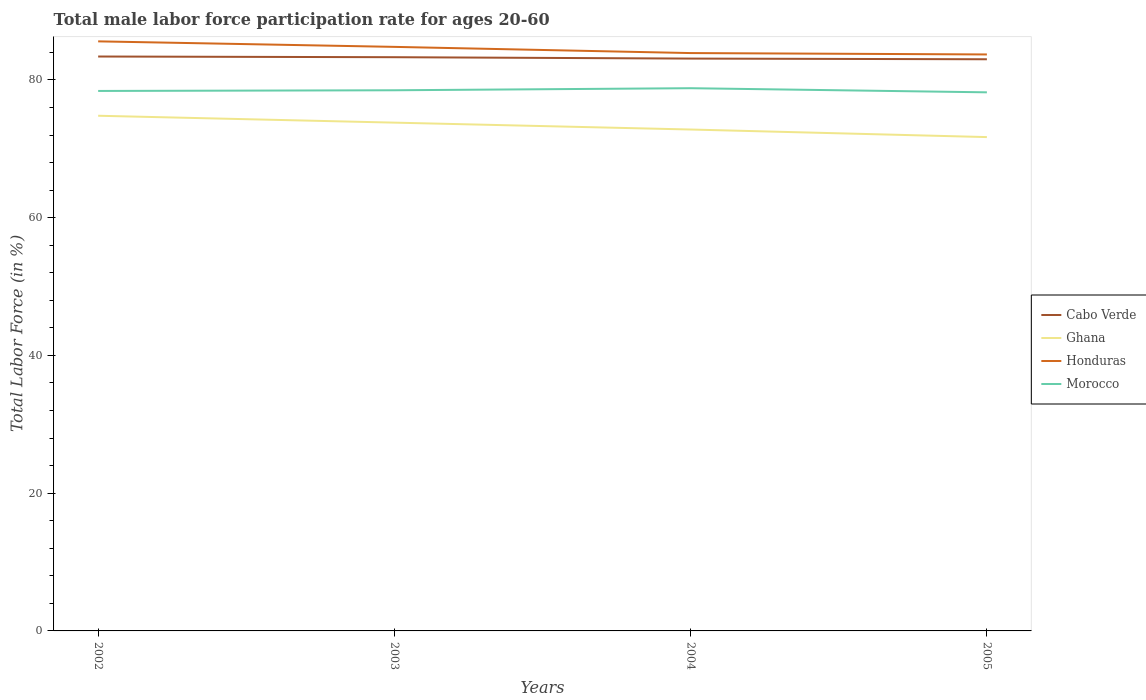How many different coloured lines are there?
Your answer should be compact. 4. Does the line corresponding to Ghana intersect with the line corresponding to Morocco?
Provide a succinct answer. No. Across all years, what is the maximum male labor force participation rate in Honduras?
Give a very brief answer. 83.7. What is the total male labor force participation rate in Honduras in the graph?
Provide a short and direct response. 1.7. What is the difference between the highest and the second highest male labor force participation rate in Honduras?
Make the answer very short. 1.9. How many years are there in the graph?
Offer a terse response. 4. Are the values on the major ticks of Y-axis written in scientific E-notation?
Provide a short and direct response. No. Does the graph contain any zero values?
Provide a short and direct response. No. Where does the legend appear in the graph?
Keep it short and to the point. Center right. How are the legend labels stacked?
Provide a short and direct response. Vertical. What is the title of the graph?
Ensure brevity in your answer.  Total male labor force participation rate for ages 20-60. What is the label or title of the X-axis?
Your response must be concise. Years. What is the Total Labor Force (in %) of Cabo Verde in 2002?
Make the answer very short. 83.4. What is the Total Labor Force (in %) in Ghana in 2002?
Your response must be concise. 74.8. What is the Total Labor Force (in %) in Honduras in 2002?
Your answer should be very brief. 85.6. What is the Total Labor Force (in %) in Morocco in 2002?
Give a very brief answer. 78.4. What is the Total Labor Force (in %) of Cabo Verde in 2003?
Provide a succinct answer. 83.3. What is the Total Labor Force (in %) in Ghana in 2003?
Keep it short and to the point. 73.8. What is the Total Labor Force (in %) in Honduras in 2003?
Keep it short and to the point. 84.8. What is the Total Labor Force (in %) in Morocco in 2003?
Offer a terse response. 78.5. What is the Total Labor Force (in %) of Cabo Verde in 2004?
Give a very brief answer. 83.1. What is the Total Labor Force (in %) in Ghana in 2004?
Your answer should be compact. 72.8. What is the Total Labor Force (in %) of Honduras in 2004?
Make the answer very short. 83.9. What is the Total Labor Force (in %) of Morocco in 2004?
Keep it short and to the point. 78.8. What is the Total Labor Force (in %) of Cabo Verde in 2005?
Make the answer very short. 83. What is the Total Labor Force (in %) in Ghana in 2005?
Make the answer very short. 71.7. What is the Total Labor Force (in %) of Honduras in 2005?
Your answer should be compact. 83.7. What is the Total Labor Force (in %) of Morocco in 2005?
Provide a succinct answer. 78.2. Across all years, what is the maximum Total Labor Force (in %) in Cabo Verde?
Give a very brief answer. 83.4. Across all years, what is the maximum Total Labor Force (in %) of Ghana?
Keep it short and to the point. 74.8. Across all years, what is the maximum Total Labor Force (in %) in Honduras?
Your answer should be compact. 85.6. Across all years, what is the maximum Total Labor Force (in %) in Morocco?
Your answer should be very brief. 78.8. Across all years, what is the minimum Total Labor Force (in %) of Cabo Verde?
Your answer should be compact. 83. Across all years, what is the minimum Total Labor Force (in %) in Ghana?
Make the answer very short. 71.7. Across all years, what is the minimum Total Labor Force (in %) of Honduras?
Keep it short and to the point. 83.7. Across all years, what is the minimum Total Labor Force (in %) in Morocco?
Your answer should be compact. 78.2. What is the total Total Labor Force (in %) of Cabo Verde in the graph?
Offer a terse response. 332.8. What is the total Total Labor Force (in %) of Ghana in the graph?
Your response must be concise. 293.1. What is the total Total Labor Force (in %) of Honduras in the graph?
Offer a terse response. 338. What is the total Total Labor Force (in %) in Morocco in the graph?
Your response must be concise. 313.9. What is the difference between the Total Labor Force (in %) in Honduras in 2002 and that in 2003?
Offer a terse response. 0.8. What is the difference between the Total Labor Force (in %) of Morocco in 2002 and that in 2003?
Provide a short and direct response. -0.1. What is the difference between the Total Labor Force (in %) in Cabo Verde in 2002 and that in 2004?
Give a very brief answer. 0.3. What is the difference between the Total Labor Force (in %) in Ghana in 2002 and that in 2004?
Provide a short and direct response. 2. What is the difference between the Total Labor Force (in %) in Honduras in 2002 and that in 2004?
Your answer should be compact. 1.7. What is the difference between the Total Labor Force (in %) in Morocco in 2002 and that in 2004?
Keep it short and to the point. -0.4. What is the difference between the Total Labor Force (in %) in Honduras in 2002 and that in 2005?
Offer a very short reply. 1.9. What is the difference between the Total Labor Force (in %) of Honduras in 2003 and that in 2004?
Offer a very short reply. 0.9. What is the difference between the Total Labor Force (in %) in Cabo Verde in 2003 and that in 2005?
Make the answer very short. 0.3. What is the difference between the Total Labor Force (in %) in Ghana in 2003 and that in 2005?
Give a very brief answer. 2.1. What is the difference between the Total Labor Force (in %) in Honduras in 2003 and that in 2005?
Your answer should be compact. 1.1. What is the difference between the Total Labor Force (in %) of Cabo Verde in 2004 and that in 2005?
Offer a very short reply. 0.1. What is the difference between the Total Labor Force (in %) of Morocco in 2004 and that in 2005?
Offer a very short reply. 0.6. What is the difference between the Total Labor Force (in %) of Cabo Verde in 2002 and the Total Labor Force (in %) of Honduras in 2003?
Provide a short and direct response. -1.4. What is the difference between the Total Labor Force (in %) of Ghana in 2002 and the Total Labor Force (in %) of Morocco in 2003?
Keep it short and to the point. -3.7. What is the difference between the Total Labor Force (in %) in Cabo Verde in 2002 and the Total Labor Force (in %) in Ghana in 2004?
Your response must be concise. 10.6. What is the difference between the Total Labor Force (in %) in Honduras in 2002 and the Total Labor Force (in %) in Morocco in 2004?
Provide a succinct answer. 6.8. What is the difference between the Total Labor Force (in %) in Cabo Verde in 2002 and the Total Labor Force (in %) in Morocco in 2005?
Offer a terse response. 5.2. What is the difference between the Total Labor Force (in %) in Ghana in 2002 and the Total Labor Force (in %) in Honduras in 2005?
Offer a very short reply. -8.9. What is the difference between the Total Labor Force (in %) in Cabo Verde in 2003 and the Total Labor Force (in %) in Honduras in 2004?
Provide a succinct answer. -0.6. What is the difference between the Total Labor Force (in %) of Honduras in 2003 and the Total Labor Force (in %) of Morocco in 2004?
Offer a terse response. 6. What is the difference between the Total Labor Force (in %) of Cabo Verde in 2003 and the Total Labor Force (in %) of Honduras in 2005?
Give a very brief answer. -0.4. What is the difference between the Total Labor Force (in %) in Cabo Verde in 2003 and the Total Labor Force (in %) in Morocco in 2005?
Your answer should be compact. 5.1. What is the difference between the Total Labor Force (in %) of Ghana in 2003 and the Total Labor Force (in %) of Morocco in 2005?
Make the answer very short. -4.4. What is the difference between the Total Labor Force (in %) of Honduras in 2003 and the Total Labor Force (in %) of Morocco in 2005?
Make the answer very short. 6.6. What is the difference between the Total Labor Force (in %) in Cabo Verde in 2004 and the Total Labor Force (in %) in Morocco in 2005?
Ensure brevity in your answer.  4.9. What is the difference between the Total Labor Force (in %) of Ghana in 2004 and the Total Labor Force (in %) of Honduras in 2005?
Provide a succinct answer. -10.9. What is the difference between the Total Labor Force (in %) in Honduras in 2004 and the Total Labor Force (in %) in Morocco in 2005?
Provide a succinct answer. 5.7. What is the average Total Labor Force (in %) of Cabo Verde per year?
Keep it short and to the point. 83.2. What is the average Total Labor Force (in %) of Ghana per year?
Offer a terse response. 73.28. What is the average Total Labor Force (in %) of Honduras per year?
Your response must be concise. 84.5. What is the average Total Labor Force (in %) in Morocco per year?
Ensure brevity in your answer.  78.47. In the year 2002, what is the difference between the Total Labor Force (in %) of Cabo Verde and Total Labor Force (in %) of Ghana?
Offer a terse response. 8.6. In the year 2002, what is the difference between the Total Labor Force (in %) in Cabo Verde and Total Labor Force (in %) in Morocco?
Make the answer very short. 5. In the year 2002, what is the difference between the Total Labor Force (in %) of Ghana and Total Labor Force (in %) of Honduras?
Offer a terse response. -10.8. In the year 2002, what is the difference between the Total Labor Force (in %) of Ghana and Total Labor Force (in %) of Morocco?
Offer a terse response. -3.6. In the year 2002, what is the difference between the Total Labor Force (in %) in Honduras and Total Labor Force (in %) in Morocco?
Your answer should be compact. 7.2. In the year 2003, what is the difference between the Total Labor Force (in %) in Cabo Verde and Total Labor Force (in %) in Honduras?
Provide a short and direct response. -1.5. In the year 2003, what is the difference between the Total Labor Force (in %) of Ghana and Total Labor Force (in %) of Morocco?
Provide a short and direct response. -4.7. In the year 2004, what is the difference between the Total Labor Force (in %) of Cabo Verde and Total Labor Force (in %) of Ghana?
Ensure brevity in your answer.  10.3. In the year 2005, what is the difference between the Total Labor Force (in %) of Cabo Verde and Total Labor Force (in %) of Morocco?
Provide a short and direct response. 4.8. In the year 2005, what is the difference between the Total Labor Force (in %) in Ghana and Total Labor Force (in %) in Honduras?
Give a very brief answer. -12. What is the ratio of the Total Labor Force (in %) of Ghana in 2002 to that in 2003?
Provide a short and direct response. 1.01. What is the ratio of the Total Labor Force (in %) of Honduras in 2002 to that in 2003?
Provide a short and direct response. 1.01. What is the ratio of the Total Labor Force (in %) of Cabo Verde in 2002 to that in 2004?
Provide a short and direct response. 1. What is the ratio of the Total Labor Force (in %) of Ghana in 2002 to that in 2004?
Give a very brief answer. 1.03. What is the ratio of the Total Labor Force (in %) of Honduras in 2002 to that in 2004?
Your answer should be compact. 1.02. What is the ratio of the Total Labor Force (in %) in Morocco in 2002 to that in 2004?
Offer a very short reply. 0.99. What is the ratio of the Total Labor Force (in %) in Cabo Verde in 2002 to that in 2005?
Give a very brief answer. 1. What is the ratio of the Total Labor Force (in %) of Ghana in 2002 to that in 2005?
Keep it short and to the point. 1.04. What is the ratio of the Total Labor Force (in %) of Honduras in 2002 to that in 2005?
Your answer should be very brief. 1.02. What is the ratio of the Total Labor Force (in %) of Ghana in 2003 to that in 2004?
Give a very brief answer. 1.01. What is the ratio of the Total Labor Force (in %) in Honduras in 2003 to that in 2004?
Offer a very short reply. 1.01. What is the ratio of the Total Labor Force (in %) of Morocco in 2003 to that in 2004?
Offer a very short reply. 1. What is the ratio of the Total Labor Force (in %) of Cabo Verde in 2003 to that in 2005?
Provide a short and direct response. 1. What is the ratio of the Total Labor Force (in %) of Ghana in 2003 to that in 2005?
Give a very brief answer. 1.03. What is the ratio of the Total Labor Force (in %) in Honduras in 2003 to that in 2005?
Your response must be concise. 1.01. What is the ratio of the Total Labor Force (in %) in Cabo Verde in 2004 to that in 2005?
Give a very brief answer. 1. What is the ratio of the Total Labor Force (in %) of Ghana in 2004 to that in 2005?
Provide a short and direct response. 1.02. What is the ratio of the Total Labor Force (in %) of Honduras in 2004 to that in 2005?
Ensure brevity in your answer.  1. What is the ratio of the Total Labor Force (in %) of Morocco in 2004 to that in 2005?
Your answer should be compact. 1.01. What is the difference between the highest and the second highest Total Labor Force (in %) in Honduras?
Your answer should be very brief. 0.8. What is the difference between the highest and the lowest Total Labor Force (in %) in Cabo Verde?
Provide a succinct answer. 0.4. What is the difference between the highest and the lowest Total Labor Force (in %) in Ghana?
Offer a terse response. 3.1. 